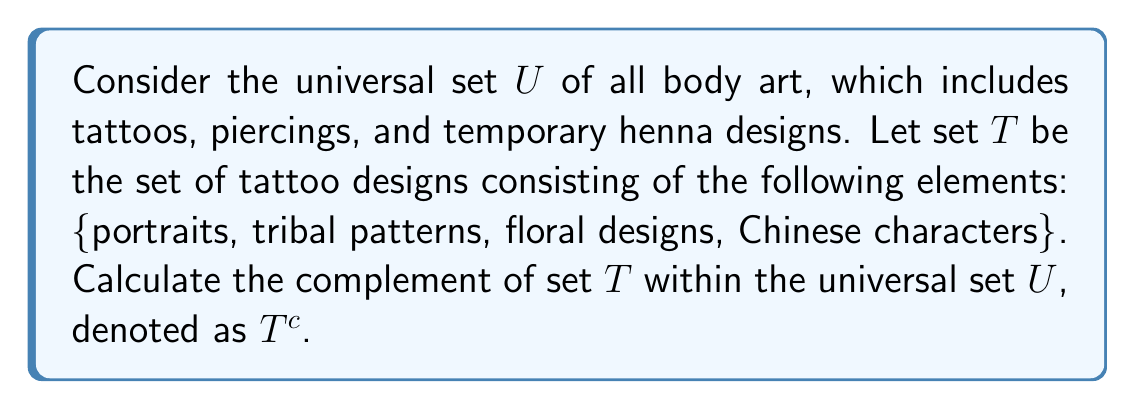Provide a solution to this math problem. To find the complement of set $T$, we need to identify all elements in the universal set $U$ that are not in set $T$. Let's approach this step-by-step:

1. First, let's define the universal set $U$:
   $U$ = {portraits, tribal patterns, floral designs, Chinese characters, piercings, temporary henna designs}

2. We are given set $T$:
   $T$ = {portraits, tribal patterns, floral designs, Chinese characters}

3. The complement of $T$, denoted as $T^c$, is defined as:
   $T^c = \{x \in U : x \notin T\}$

4. To find $T^c$, we need to identify all elements in $U$ that are not in $T$:
   - piercings $\in U$ but $\notin T$
   - temporary henna designs $\in U$ but $\notin T$

5. Therefore, the complement of $T$ is:
   $T^c = \{$piercings, temporary henna designs$\}$

This result shows that the complement of the set of tattoo designs includes all other forms of body art that are not permanent tattoos.
Answer: $T^c = \{$piercings, temporary henna designs$\}$ 